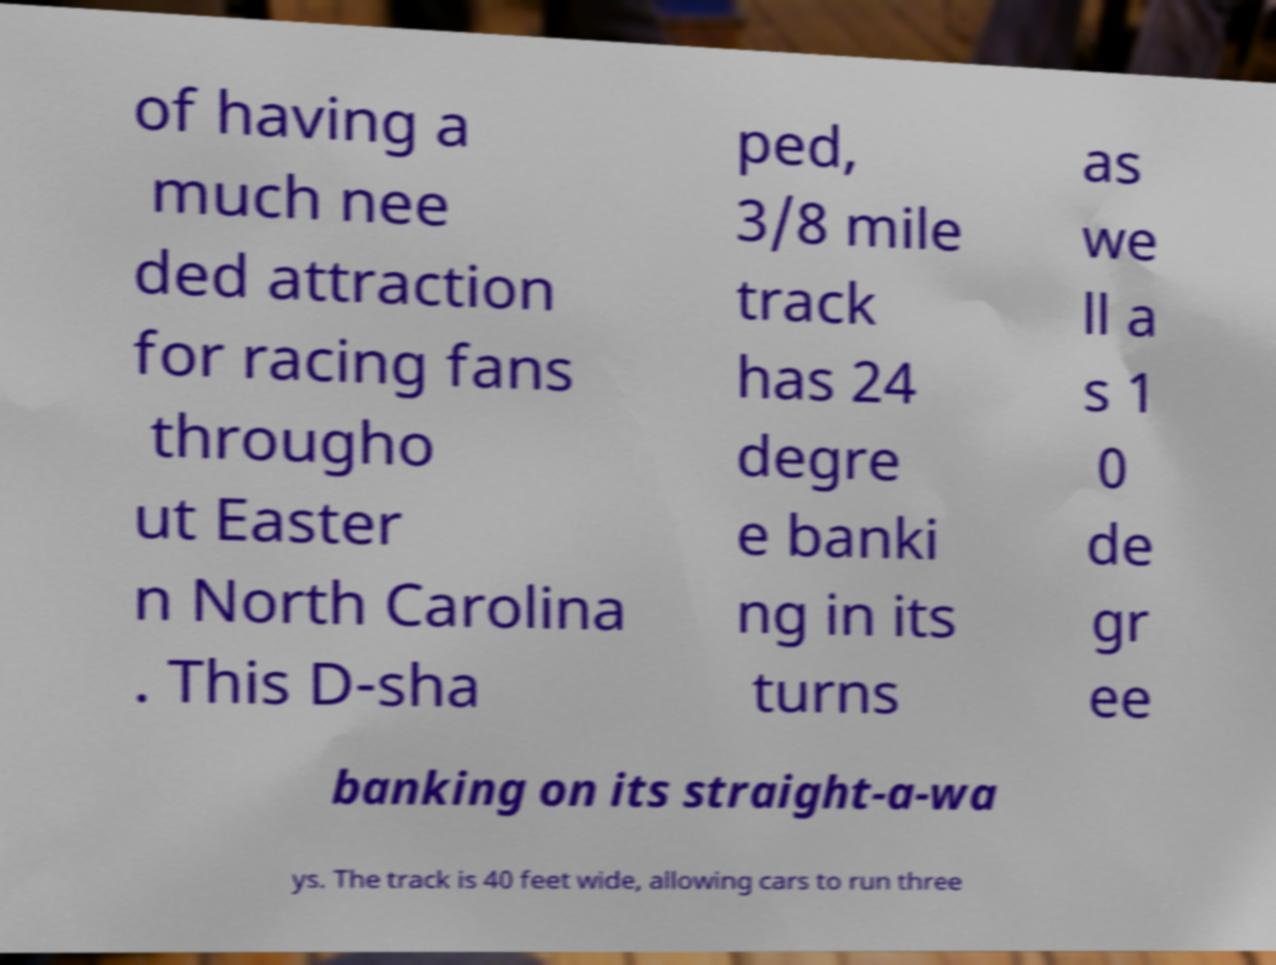Please read and relay the text visible in this image. What does it say? of having a much nee ded attraction for racing fans througho ut Easter n North Carolina . This D-sha ped, 3/8 mile track has 24 degre e banki ng in its turns as we ll a s 1 0 de gr ee banking on its straight-a-wa ys. The track is 40 feet wide, allowing cars to run three 